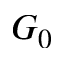<formula> <loc_0><loc_0><loc_500><loc_500>G _ { 0 }</formula> 